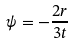Convert formula to latex. <formula><loc_0><loc_0><loc_500><loc_500>\psi = - { \frac { 2 r } { 3 t } }</formula> 